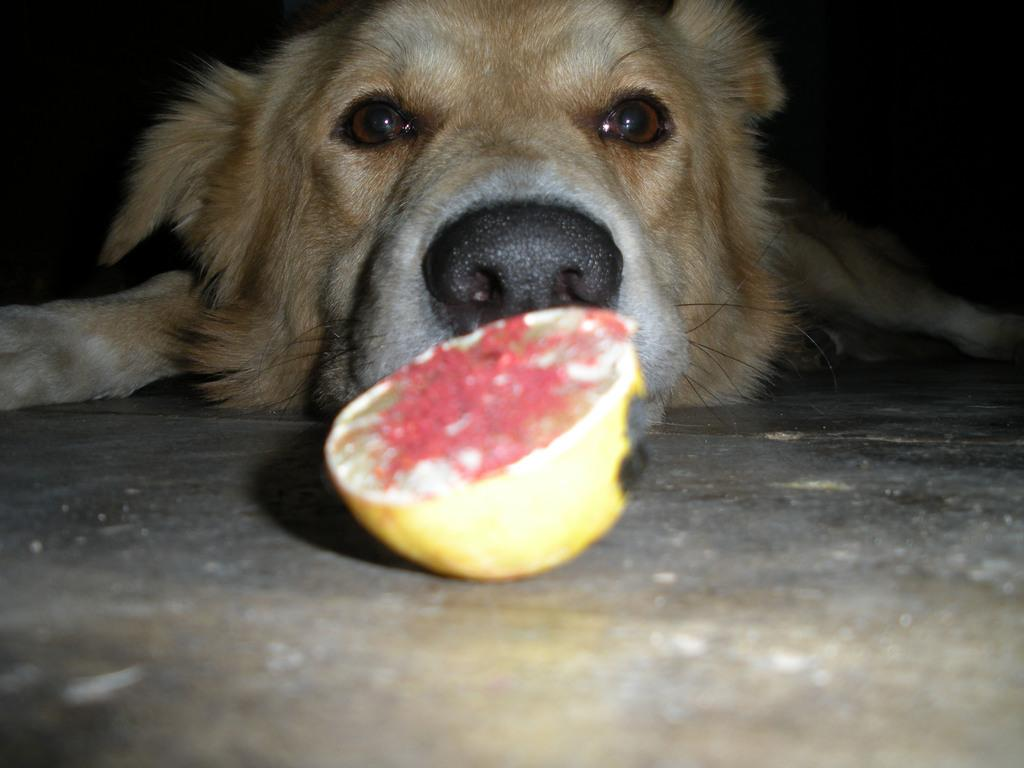What is the main subject in the center of the image? There is a dog in the center of the image. What other objects can be seen in the image? There are fruits visible in the image. What part of the environment is visible at the bottom of the image? The floor is visible at the bottom of the image. What type of table is the dog sitting on in the image? There is no table present in the image; the dog is standing on the floor. 